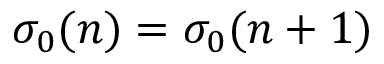<formula> <loc_0><loc_0><loc_500><loc_500>\sigma _ { 0 } ( n ) = \sigma _ { 0 } ( n + 1 )</formula> 